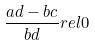<formula> <loc_0><loc_0><loc_500><loc_500>\frac { a d - b c } { b d } r e l 0</formula> 